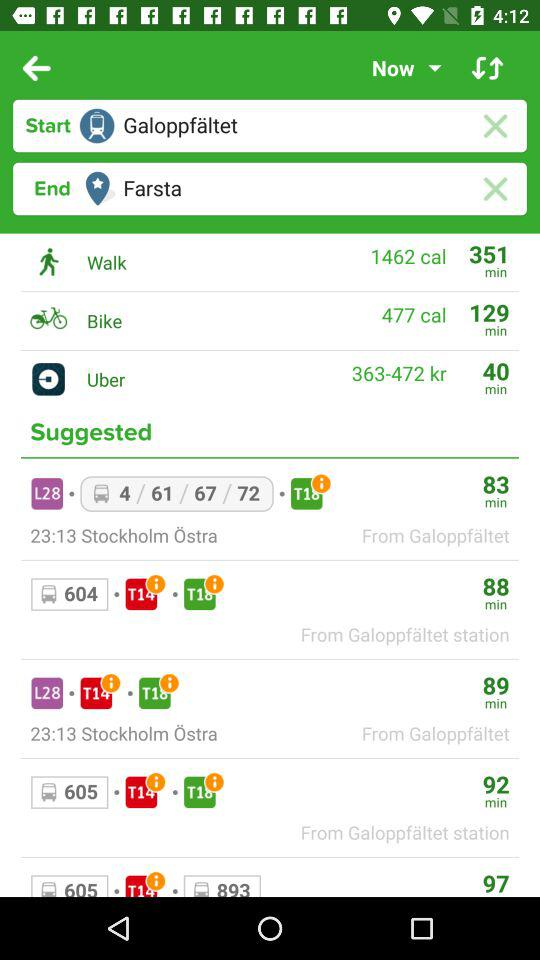How much time does it take on Uber? The time it takes on Uber is 40 minutes. 